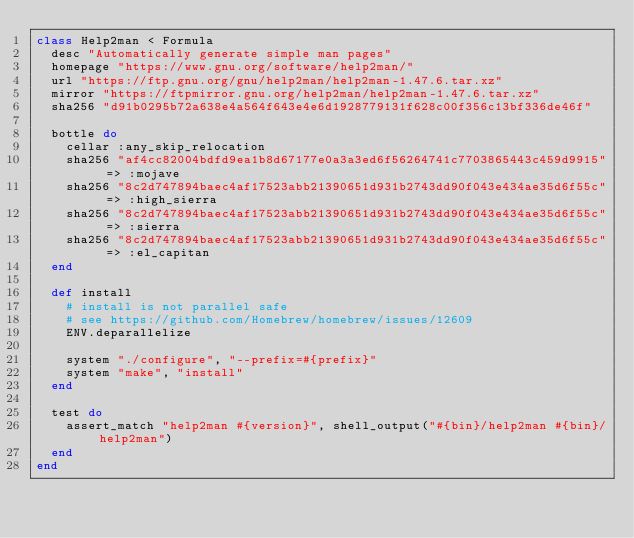<code> <loc_0><loc_0><loc_500><loc_500><_Ruby_>class Help2man < Formula
  desc "Automatically generate simple man pages"
  homepage "https://www.gnu.org/software/help2man/"
  url "https://ftp.gnu.org/gnu/help2man/help2man-1.47.6.tar.xz"
  mirror "https://ftpmirror.gnu.org/help2man/help2man-1.47.6.tar.xz"
  sha256 "d91b0295b72a638e4a564f643e4e6d1928779131f628c00f356c13bf336de46f"

  bottle do
    cellar :any_skip_relocation
    sha256 "af4cc82004bdfd9ea1b8d67177e0a3a3ed6f56264741c7703865443c459d9915" => :mojave
    sha256 "8c2d747894baec4af17523abb21390651d931b2743dd90f043e434ae35d6f55c" => :high_sierra
    sha256 "8c2d747894baec4af17523abb21390651d931b2743dd90f043e434ae35d6f55c" => :sierra
    sha256 "8c2d747894baec4af17523abb21390651d931b2743dd90f043e434ae35d6f55c" => :el_capitan
  end

  def install
    # install is not parallel safe
    # see https://github.com/Homebrew/homebrew/issues/12609
    ENV.deparallelize

    system "./configure", "--prefix=#{prefix}"
    system "make", "install"
  end

  test do
    assert_match "help2man #{version}", shell_output("#{bin}/help2man #{bin}/help2man")
  end
end
</code> 